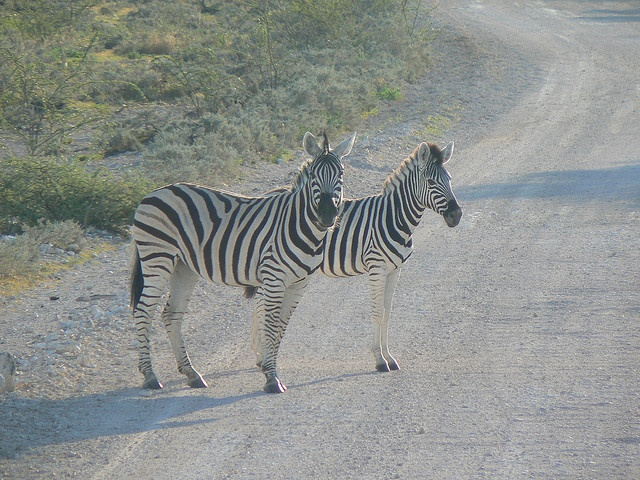Describe the objects in this image and their specific colors. I can see zebra in gray, darkgray, and black tones and zebra in gray, darkgray, black, and purple tones in this image. 